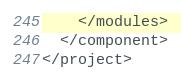<code> <loc_0><loc_0><loc_500><loc_500><_XML_>    </modules>
  </component>
</project></code> 